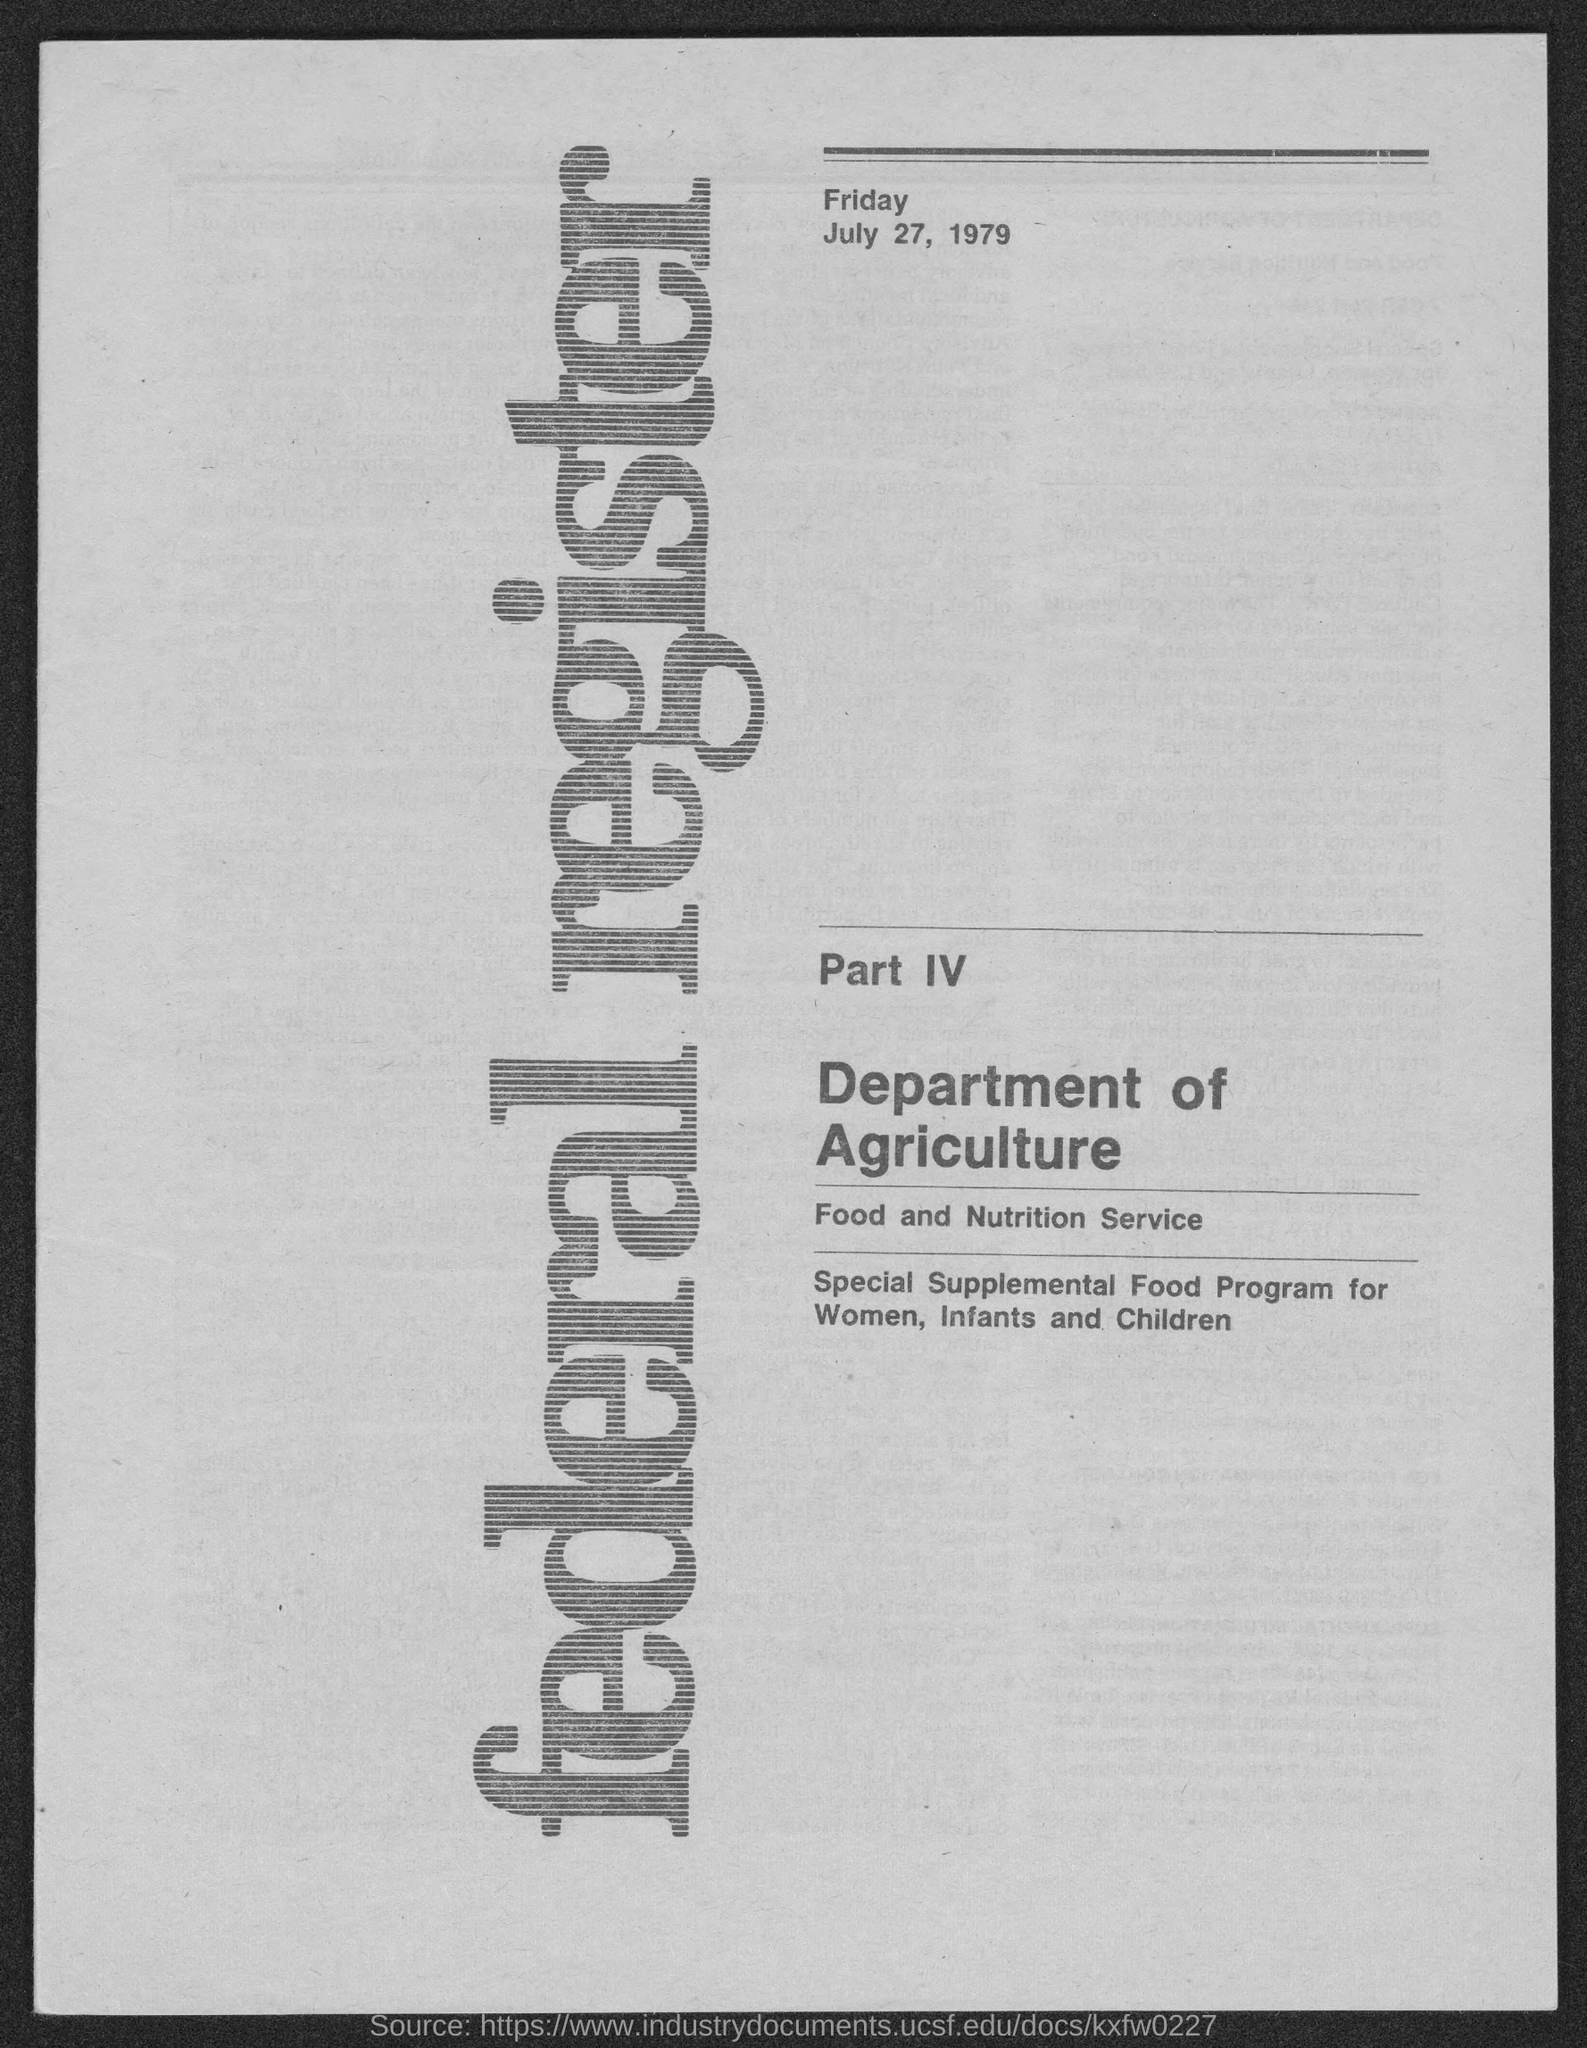Give some essential details in this illustration. The Federal Register is a register mentioned in the given page. The Food and Nutrition Service is the name of the service mentioned in the given page. The date mentioned in the given page is July 27, 1979. The day mentioned in the given page is Friday. The Special Supplemental Food Program was conducted for the benefit of women, infants, and children. 